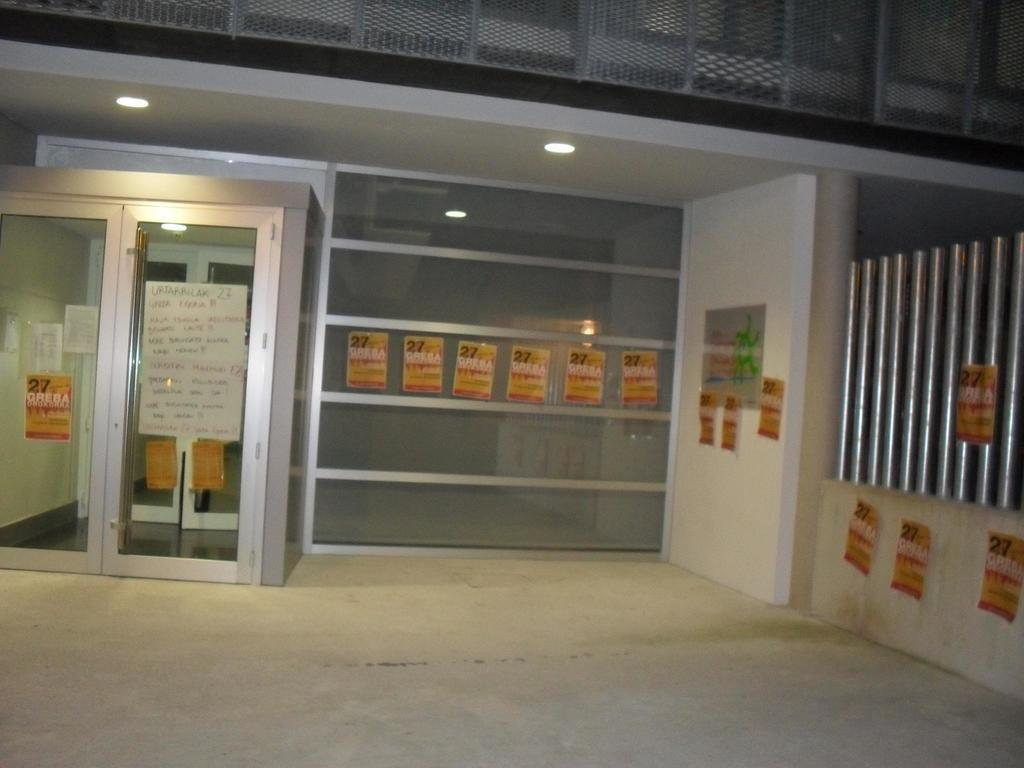What type of structure is present in the image? There is an iron grill in the image. What type of lighting is visible in the image? There are electric lights in the image. What architectural feature can be seen in the image? There are windows in the image. What surface is visible in the image? The floor is visible in the image. Can you tell me what thought the electric lights are having in the image? Electric lights do not have thoughts, as they are inanimate objects. What invention is being used for swimming in the image? There is no swimming or invention related to swimming present in the image. 